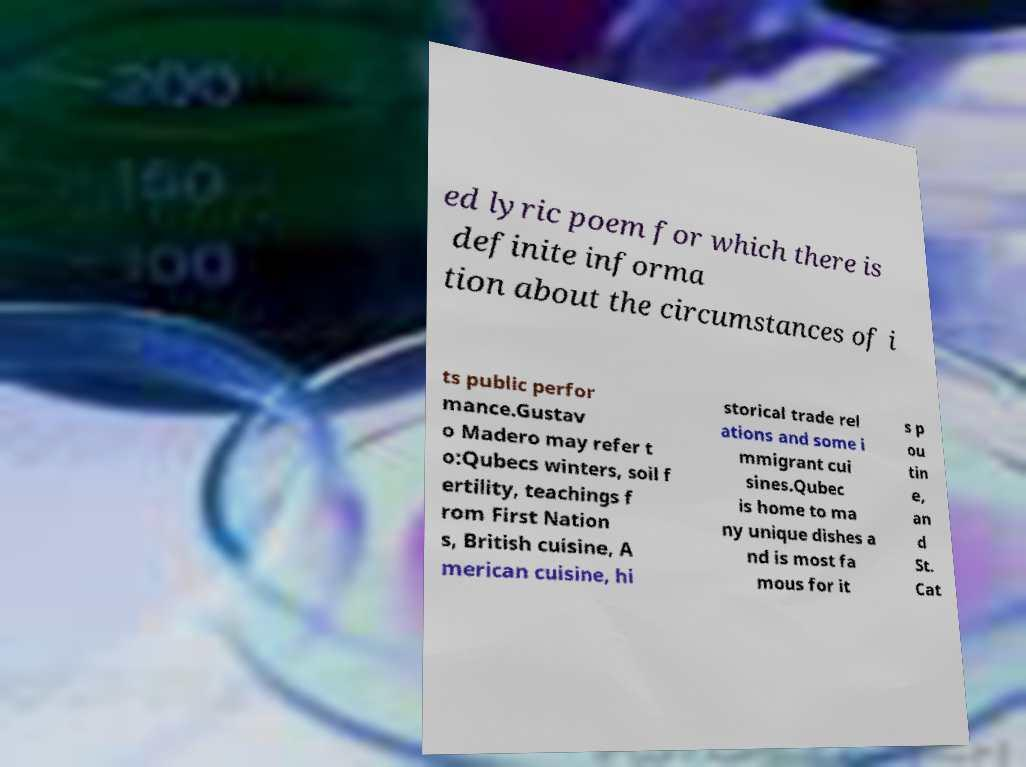Could you extract and type out the text from this image? ed lyric poem for which there is definite informa tion about the circumstances of i ts public perfor mance.Gustav o Madero may refer t o:Qubecs winters, soil f ertility, teachings f rom First Nation s, British cuisine, A merican cuisine, hi storical trade rel ations and some i mmigrant cui sines.Qubec is home to ma ny unique dishes a nd is most fa mous for it s p ou tin e, an d St. Cat 